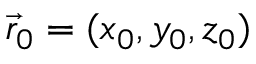<formula> <loc_0><loc_0><loc_500><loc_500>\vec { r } _ { 0 } = ( x _ { 0 } , y _ { 0 } , z _ { 0 } )</formula> 